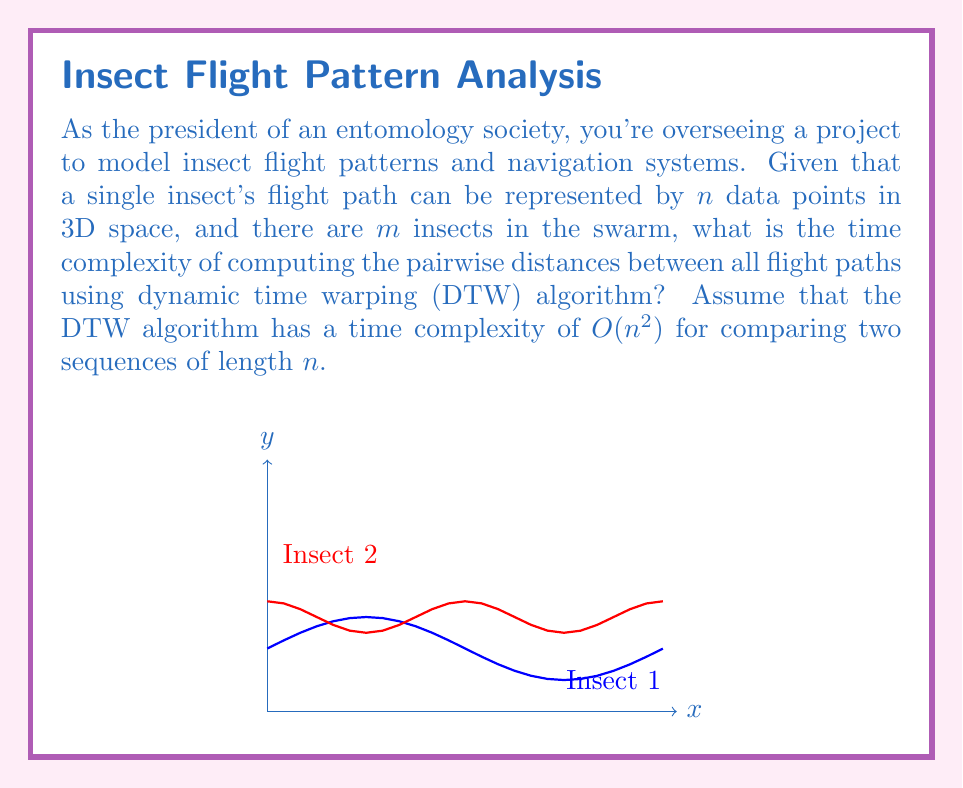Give your solution to this math problem. To solve this problem, let's break it down step-by-step:

1) First, we need to understand what the question is asking. We're comparing the flight paths of $m$ insects, where each flight path is represented by $n$ points in 3D space.

2) We need to compute the pairwise distances between all flight paths. This means we need to compare each flight path with every other flight path.

3) The number of pairwise comparisons for $m$ insects is:

   $$\binom{m}{2} = \frac{m(m-1)}{2}$$

4) For each comparison, we're using the DTW algorithm, which has a time complexity of $O(n^2)$ for sequences of length $n$.

5) Therefore, for each pairwise comparison, we're performing $O(n^2)$ operations.

6) We need to do this $\frac{m(m-1)}{2}$ times.

7) Multiplying these together, we get:

   $$O\left(\frac{m(m-1)}{2} \cdot n^2\right)$$

8) Simplifying this expression:

   $$O(m^2n^2)$$

9) In Big O notation, we drop constant factors, so the final time complexity is $O(m^2n^2)$.

This means that the time complexity grows quadratically with both the number of insects ($m$) and the number of data points per flight path ($n$).
Answer: $O(m^2n^2)$ 